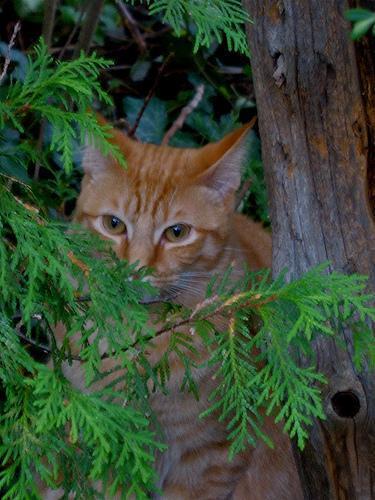How many cats are there?
Give a very brief answer. 1. How many trees are there?
Give a very brief answer. 1. 